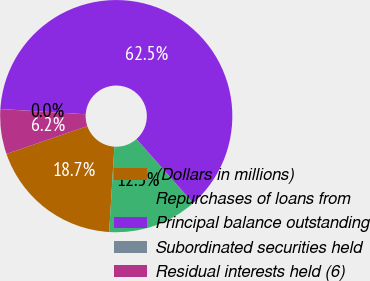<chart> <loc_0><loc_0><loc_500><loc_500><pie_chart><fcel>(Dollars in millions)<fcel>Repurchases of loans from<fcel>Principal balance outstanding<fcel>Subordinated securities held<fcel>Residual interests held (6)<nl><fcel>18.75%<fcel>12.5%<fcel>62.49%<fcel>0.01%<fcel>6.25%<nl></chart> 